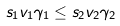Convert formula to latex. <formula><loc_0><loc_0><loc_500><loc_500>s _ { 1 } v _ { 1 } \gamma _ { 1 } \leq s _ { 2 } v _ { 2 } \gamma _ { 2 }</formula> 